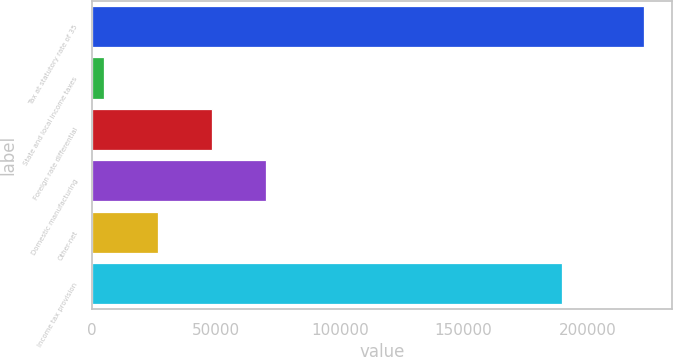Convert chart. <chart><loc_0><loc_0><loc_500><loc_500><bar_chart><fcel>Tax at statutory rate of 35<fcel>State and local income taxes<fcel>Foreign rate differential<fcel>Domestic manufacturing<fcel>Other-net<fcel>Income tax provision<nl><fcel>222888<fcel>4931<fcel>48522.4<fcel>70318.1<fcel>26726.7<fcel>189612<nl></chart> 